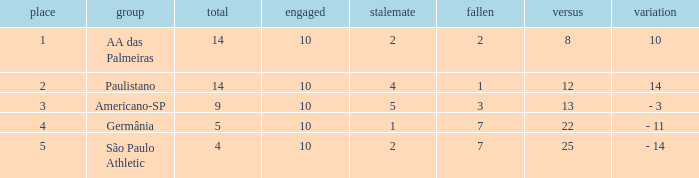What is the sum of against when the lost is greater than 7? None. 